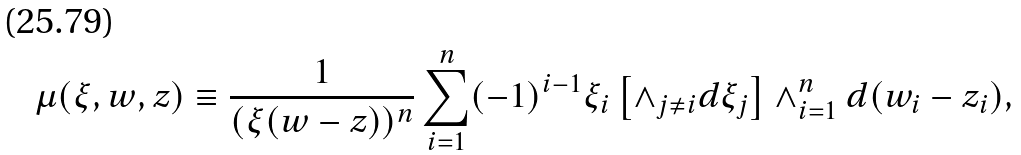<formula> <loc_0><loc_0><loc_500><loc_500>\mu ( \xi , w , z ) \equiv \frac { 1 } { ( \xi ( w - z ) ) ^ { n } } \sum _ { i = 1 } ^ { n } ( - 1 ) ^ { i - 1 } \xi _ { i } \left [ \wedge _ { j \neq i } d \xi _ { j } \right ] \wedge _ { i = 1 } ^ { n } d ( w _ { i } - z _ { i } ) ,</formula> 